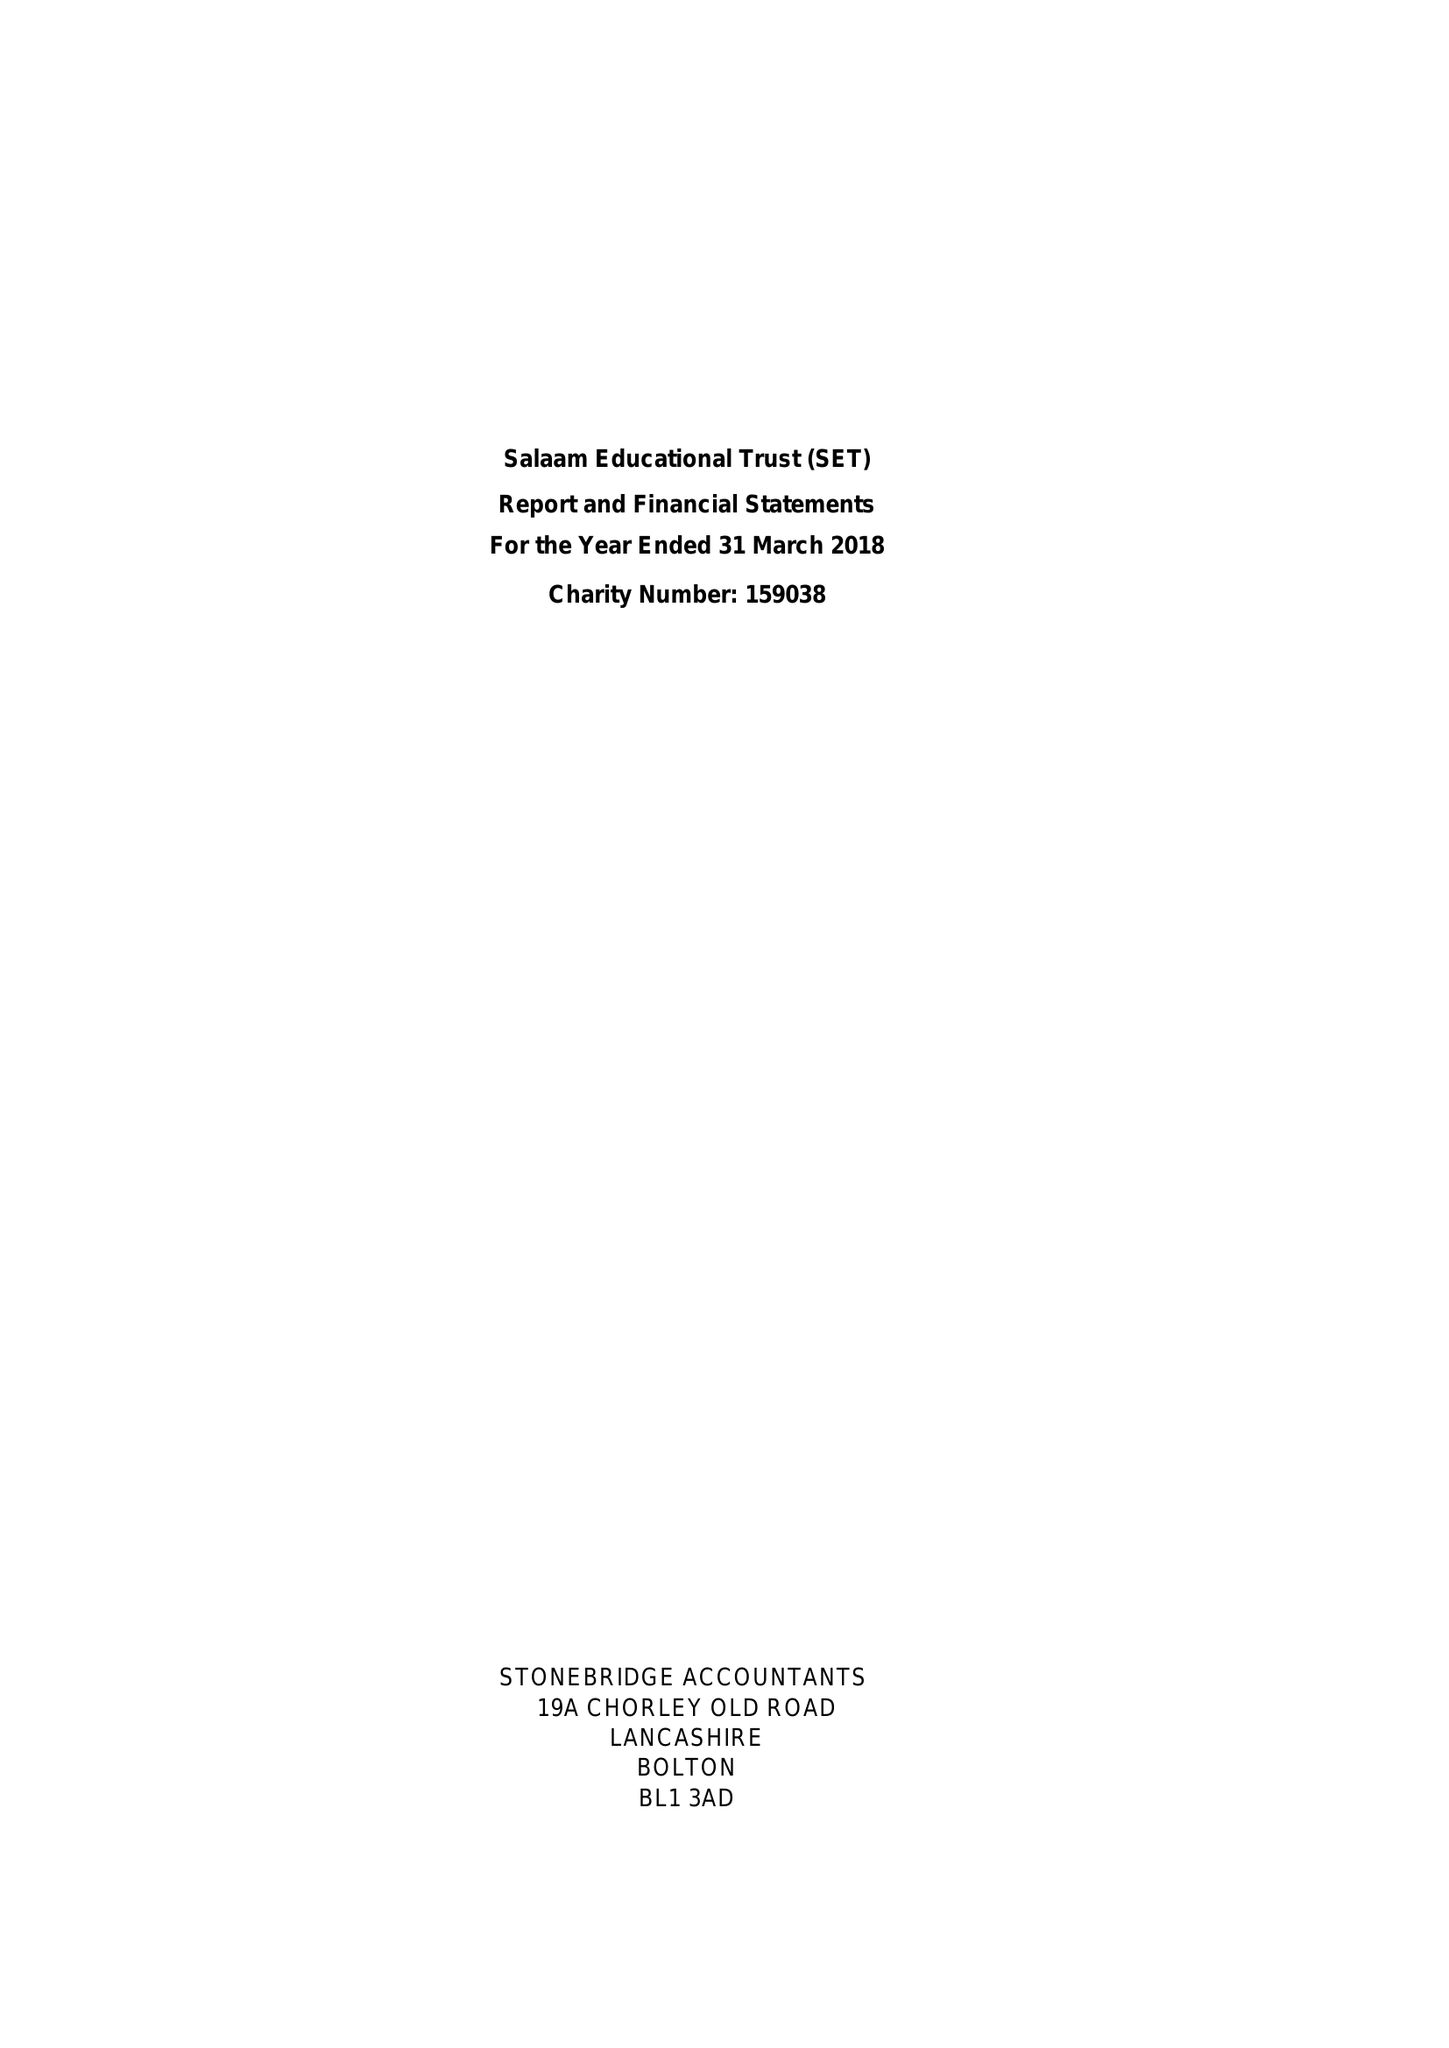What is the value for the spending_annually_in_british_pounds?
Answer the question using a single word or phrase. 37806.00 